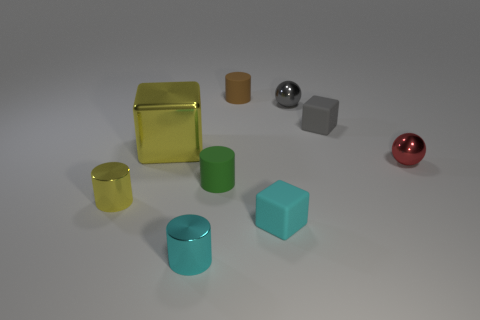Subtract 1 cylinders. How many cylinders are left? 3 Add 1 tiny matte balls. How many objects exist? 10 Subtract all cylinders. How many objects are left? 5 Add 9 cyan shiny balls. How many cyan shiny balls exist? 9 Subtract 1 yellow cylinders. How many objects are left? 8 Subtract all red things. Subtract all tiny rubber things. How many objects are left? 4 Add 3 cyan things. How many cyan things are left? 5 